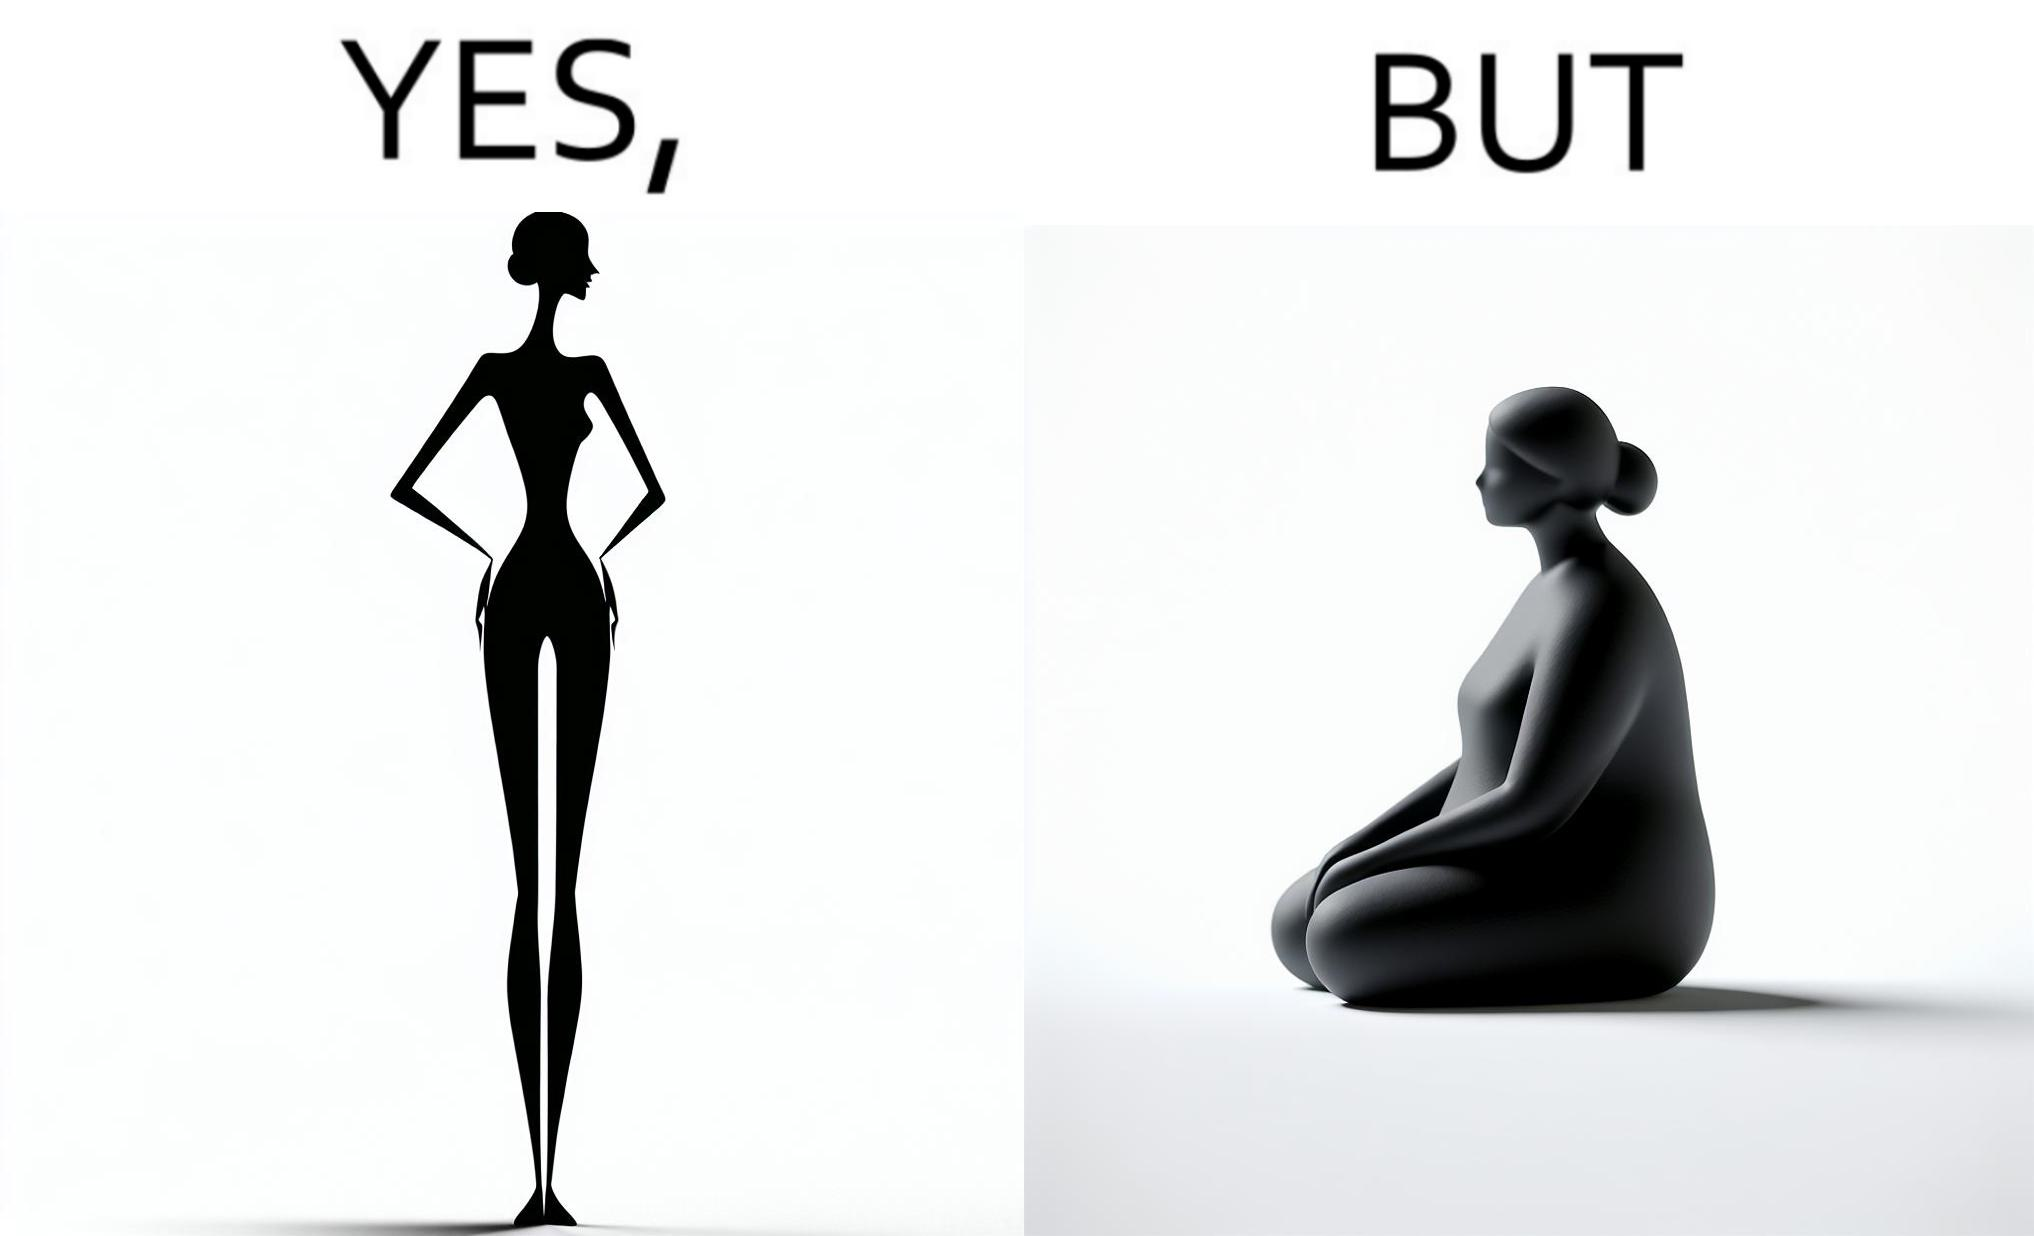What is shown in this image? the image is funny, as from the front, the woman is apparently slim, but she looks chubby from the side. 